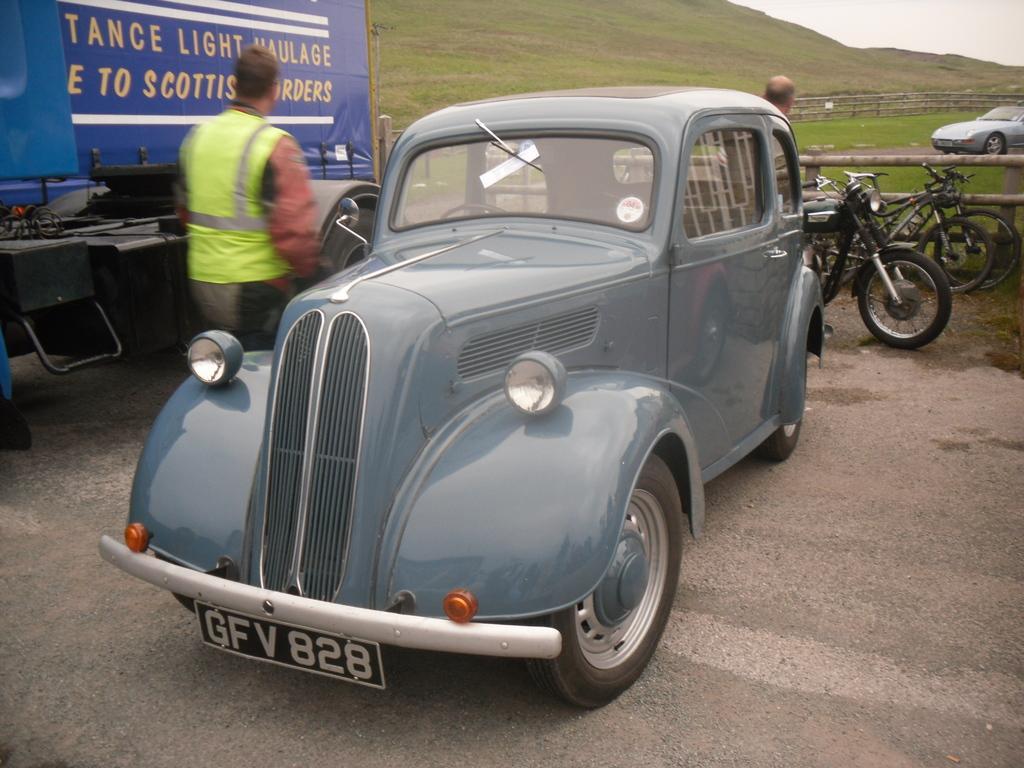Please provide a concise description of this image. On the left side, there is a person in a light green color jacket, beside him, there is a vehicle and there is a gray color vehicle parked on the road. In the background, there are bikes, a person, fences, a mountain and sky. 